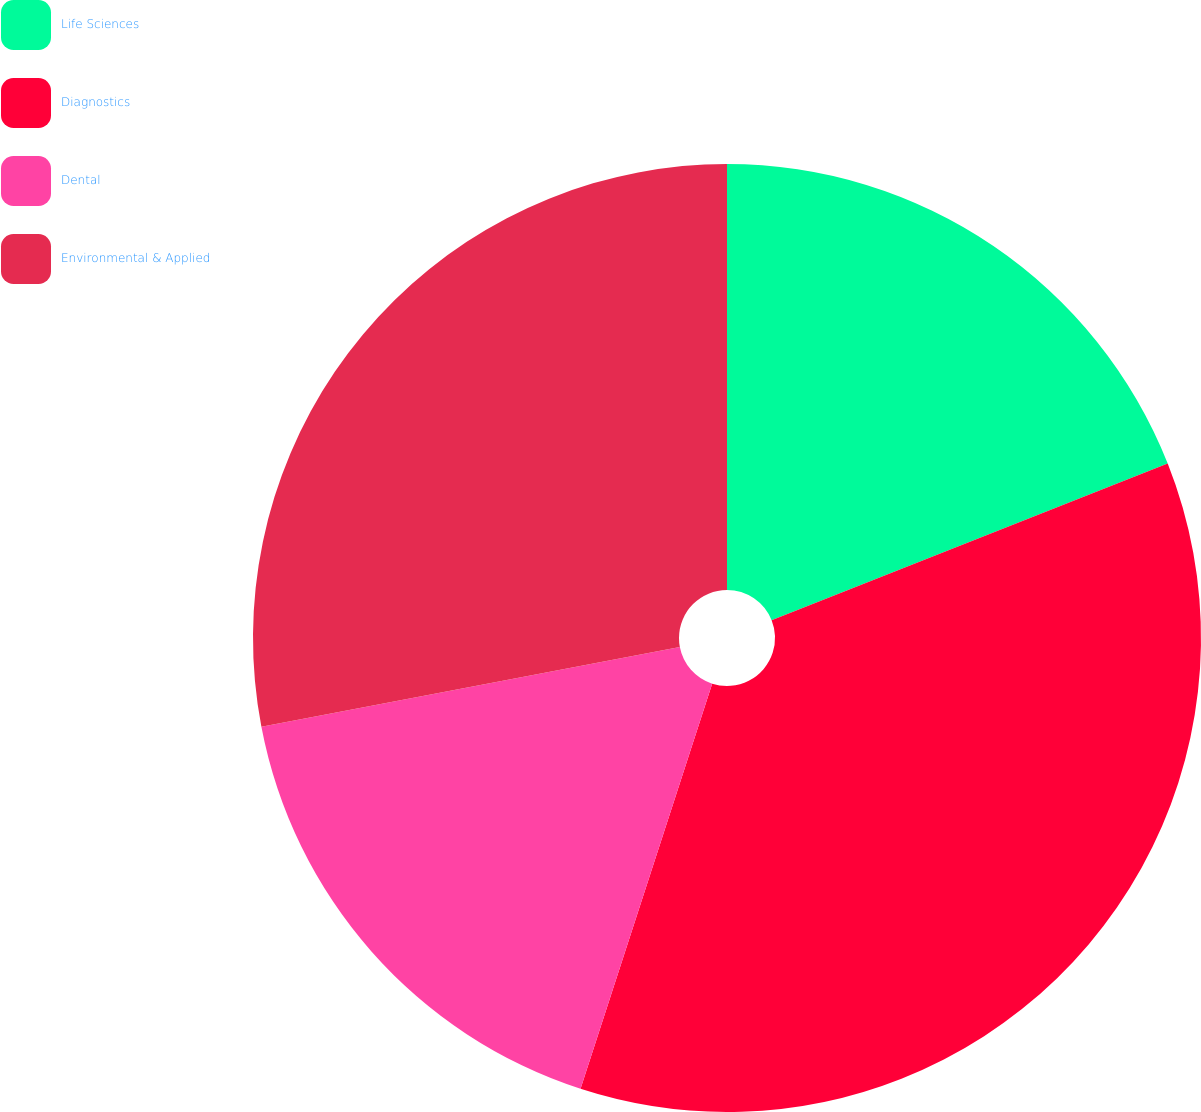<chart> <loc_0><loc_0><loc_500><loc_500><pie_chart><fcel>Life Sciences<fcel>Diagnostics<fcel>Dental<fcel>Environmental & Applied<nl><fcel>19.0%<fcel>36.0%<fcel>17.0%<fcel>28.0%<nl></chart> 